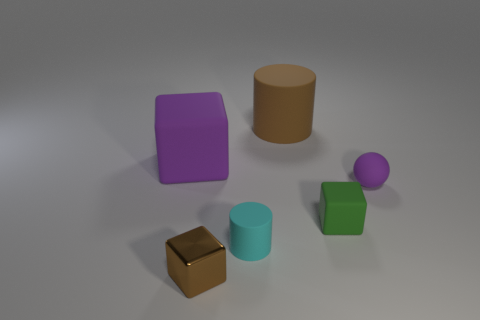What shape is the object that is the same color as the shiny cube?
Make the answer very short. Cylinder. What is the material of the brown object that is the same shape as the green thing?
Your answer should be compact. Metal. There is a block that is left of the tiny cyan object and to the right of the purple cube; what color is it?
Make the answer very short. Brown. Are there any brown rubber cylinders?
Provide a succinct answer. Yes. Are there the same number of shiny things to the right of the small cyan matte object and large matte balls?
Ensure brevity in your answer.  Yes. How many other objects are there of the same shape as the brown shiny thing?
Provide a succinct answer. 2. What is the shape of the large purple thing?
Your response must be concise. Cube. Are the small ball and the large purple cube made of the same material?
Your response must be concise. Yes. Is the number of tiny rubber spheres to the left of the big purple cube the same as the number of spheres that are in front of the matte ball?
Your answer should be compact. Yes. Are there any tiny blocks on the left side of the large rubber object behind the big matte thing on the left side of the tiny cyan cylinder?
Provide a short and direct response. Yes. 